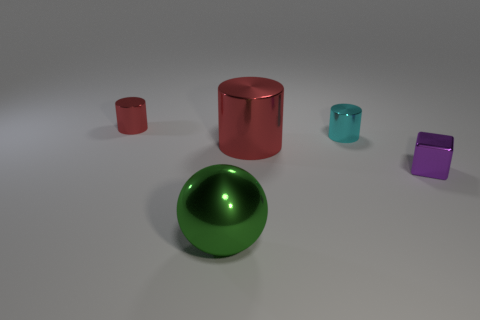Add 1 tiny green metallic cubes. How many objects exist? 6 Subtract all cubes. How many objects are left? 4 Subtract all small cyan cylinders. Subtract all big green metallic objects. How many objects are left? 3 Add 1 tiny red metallic things. How many tiny red metallic things are left? 2 Add 3 tiny blocks. How many tiny blocks exist? 4 Subtract 0 gray cylinders. How many objects are left? 5 